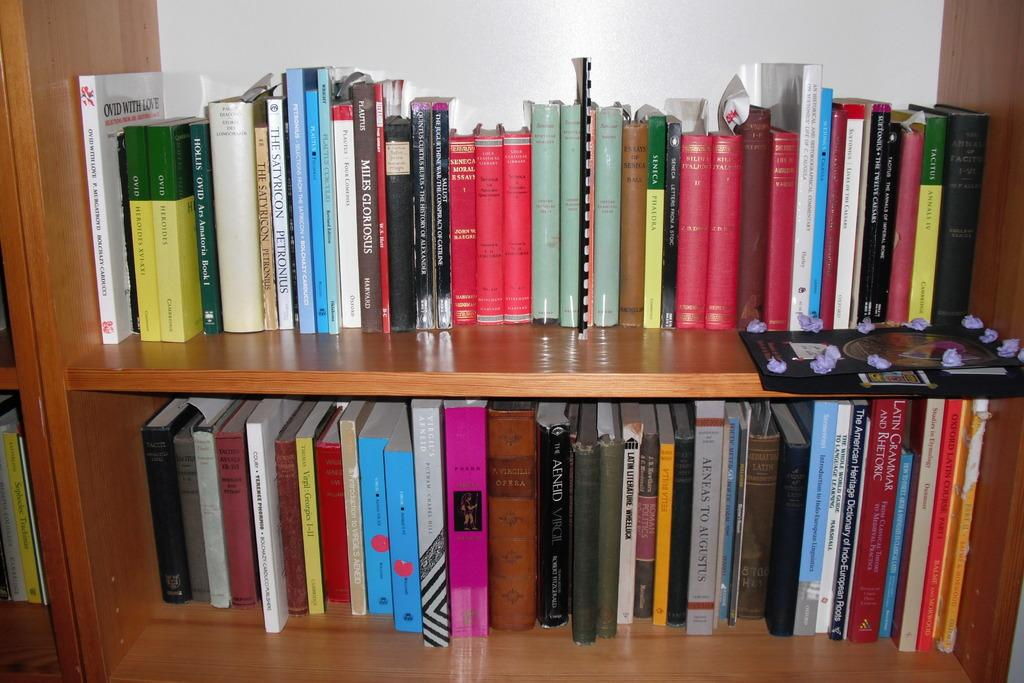What is the main object in the image? There is a book rack in the image. What is placed on the book rack? There are books in the book rack. What is the color of the wall in the image? There is a white wall in the image. What type of comfort can be seen in the image? There is no specific type of comfort visible in the image; it primarily features a book rack with books. How many copies of the same book are present in the image? There is no indication of multiple copies of the same book in the image; it shows a book rack with various books. 